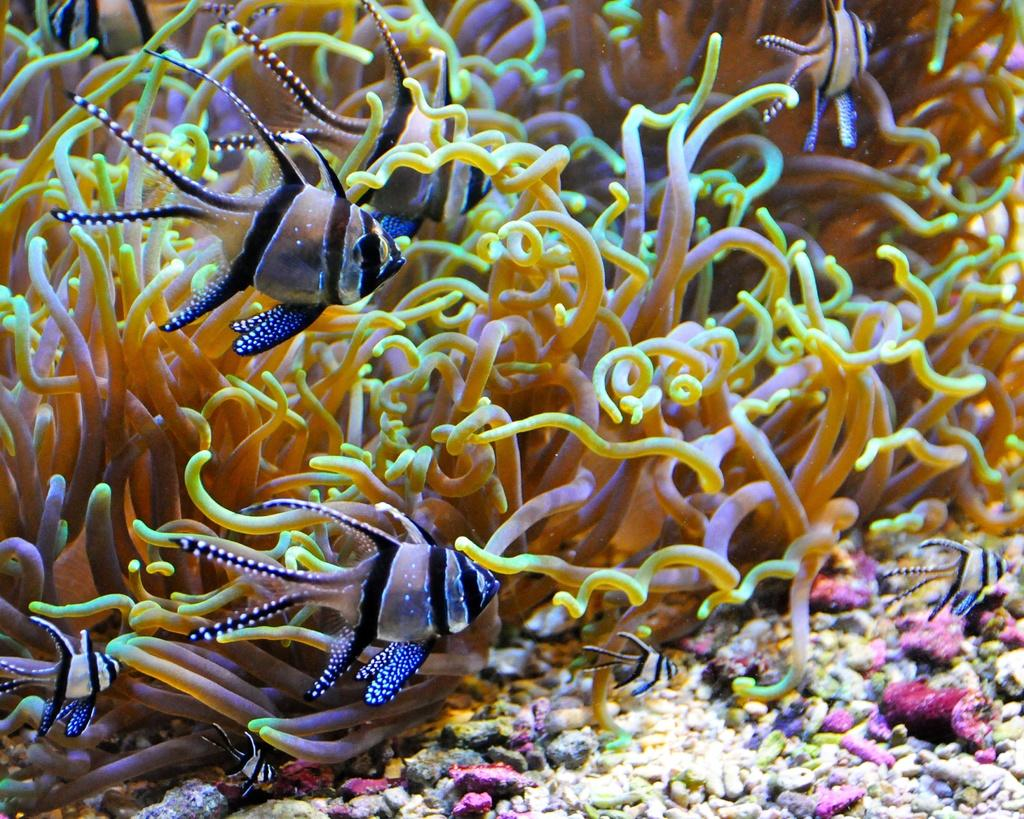Where is the image taken? The image is taken inside the water. What types of marine life can be seen in the image? There are fishes and water mammals in the image. What can be found at the bottom of the image? There are stones at the bottom of the image. What type of pie is being served at the bottom of the image? There is no pie present in the image; it is taken inside the water with fishes, water mammals, and stones at the bottom. 